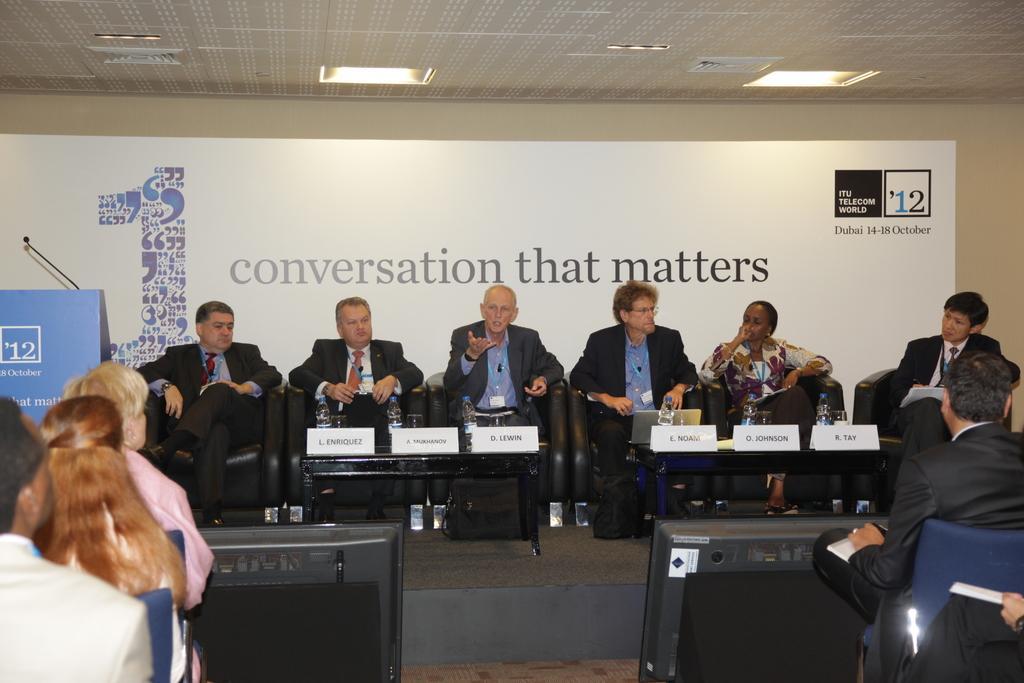Could you give a brief overview of what you see in this image? Here we can see these people sitting in front of these people. The man on the center is talking. In the background we can see a hoarding. 